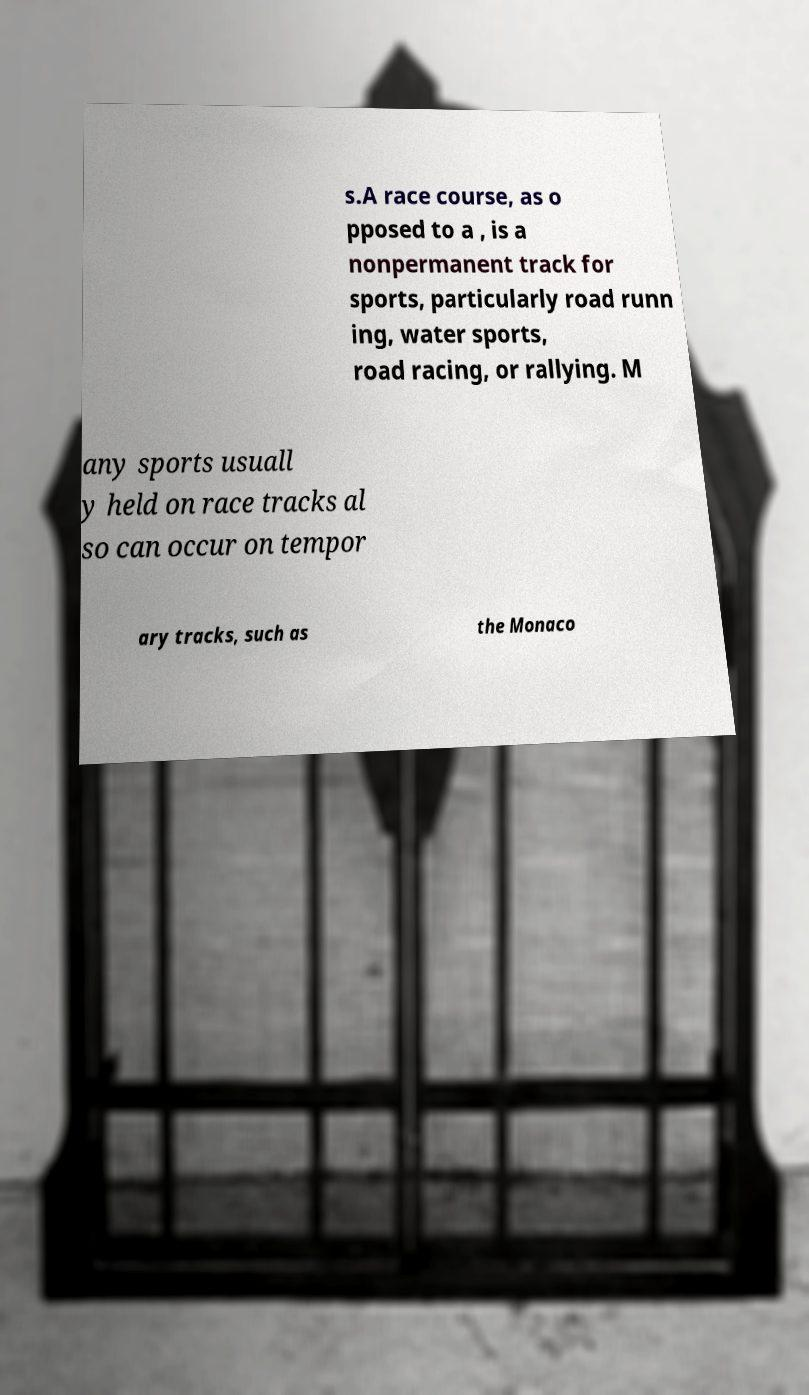What messages or text are displayed in this image? I need them in a readable, typed format. s.A race course, as o pposed to a , is a nonpermanent track for sports, particularly road runn ing, water sports, road racing, or rallying. M any sports usuall y held on race tracks al so can occur on tempor ary tracks, such as the Monaco 